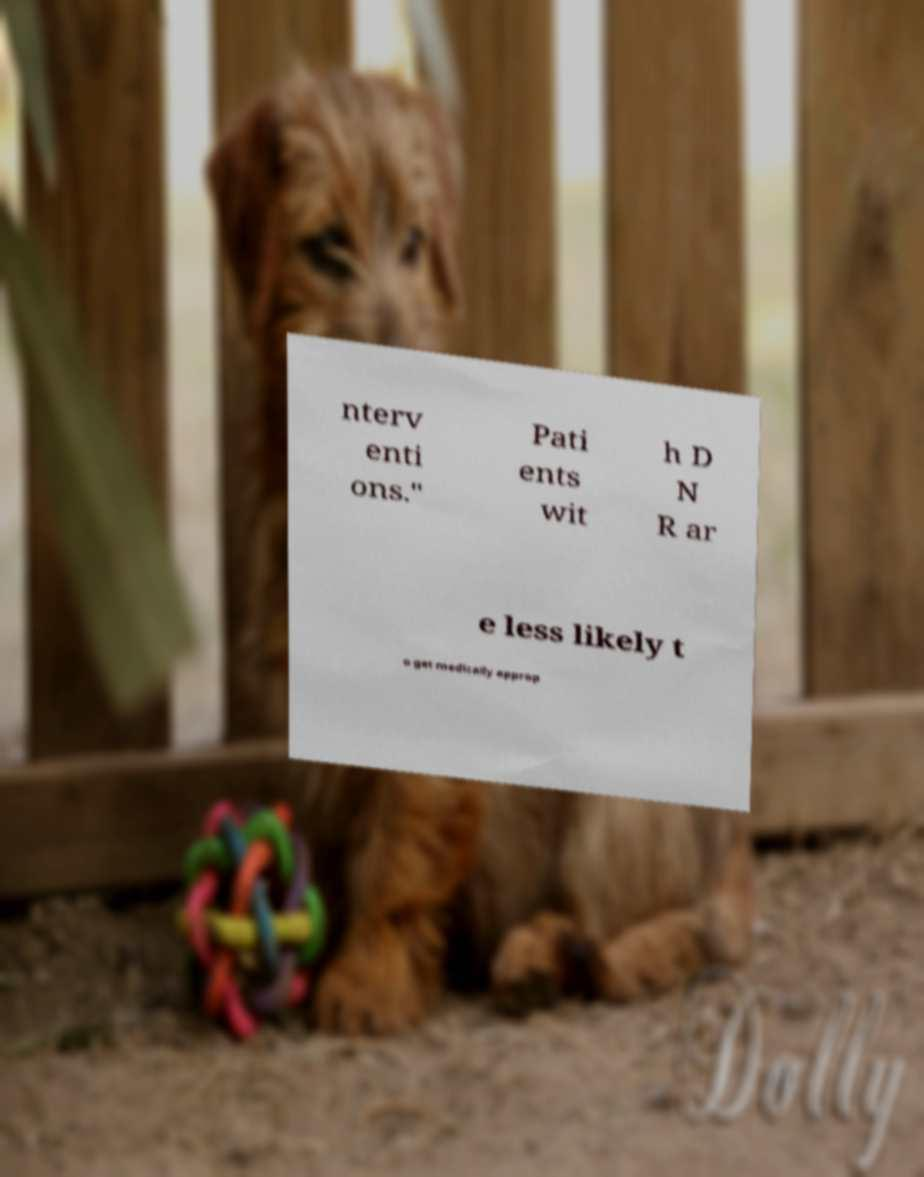I need the written content from this picture converted into text. Can you do that? nterv enti ons." Pati ents wit h D N R ar e less likely t o get medically approp 